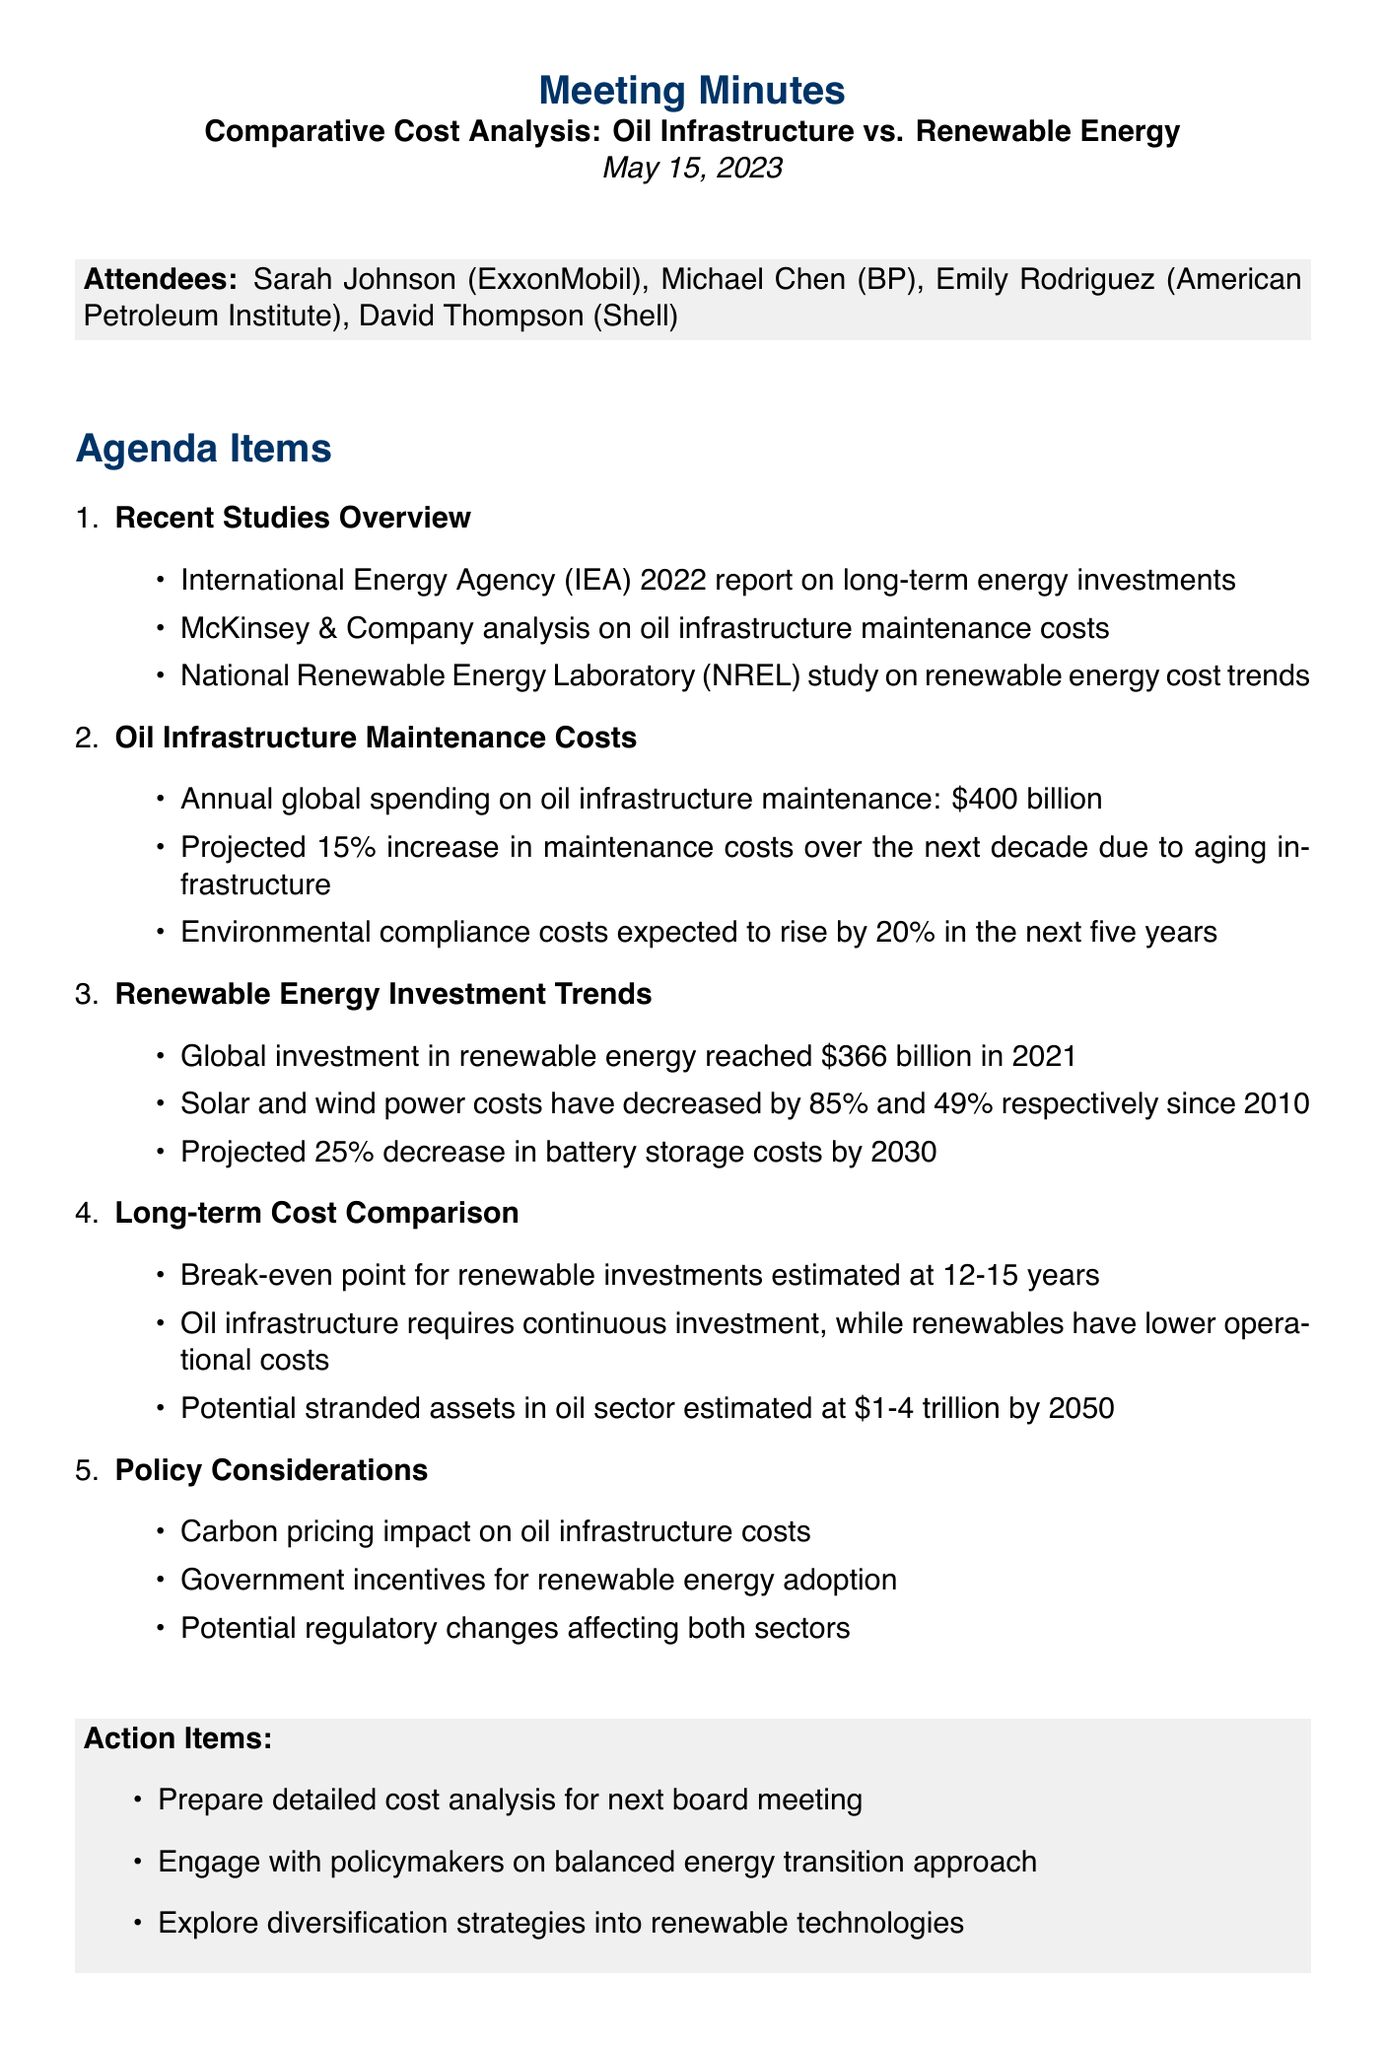What is the title of the meeting? The title of the meeting is listed at the beginning of the document as "Comparative Cost Analysis: Oil Infrastructure vs. Renewable Energy."
Answer: Comparative Cost Analysis: Oil Infrastructure vs. Renewable Energy When was the meeting held? The date of the meeting is clearly stated in the document as May 15, 2023.
Answer: May 15, 2023 What is the projected increase in oil infrastructure maintenance costs over the next decade? The document mentions a projected 15% increase in maintenance costs due to aging infrastructure.
Answer: 15% How much was the global investment in renewable energy in 2021? According to the document, the global investment in renewable energy reached $366 billion in 2021.
Answer: $366 billion What is the break-even point for renewable investments? The document states that the break-even point for renewable investments is estimated at 12-15 years.
Answer: 12-15 years What are the potential stranded assets in the oil sector estimated by 2050? The document indicates that potential stranded assets in the oil sector are estimated between $1-4 trillion by 2050.
Answer: $1-4 trillion Which company is represented by Sarah Johnson? The document lists Sarah Johnson as representing ExxonMobil during the meeting.
Answer: ExxonMobil What is one of the action items discussed at the meeting? The document includes action items, one of which is to prepare a detailed cost analysis for the next board meeting.
Answer: Prepare detailed cost analysis for next board meeting 